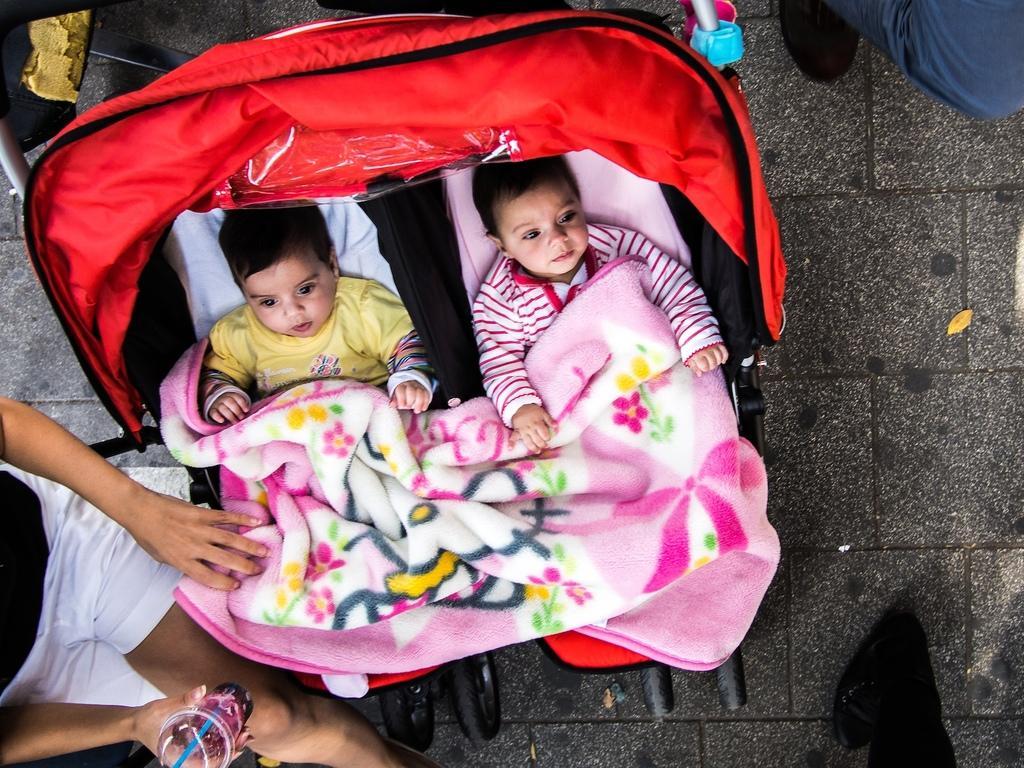Could you give a brief overview of what you see in this image? In the foreground of this image, there are two babies on a baby cart and also we can see pink and white blanket. On the left bottom, there is a person sitting and holding a glass. On the right bottom, there is a leg of a person and on the right top, there is another leg of a person. 